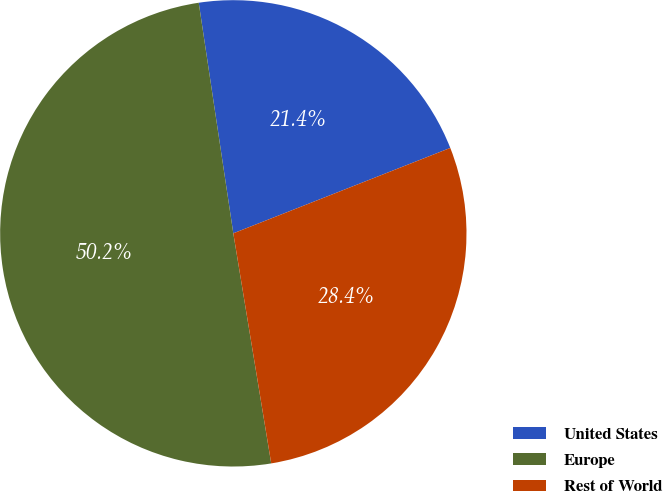<chart> <loc_0><loc_0><loc_500><loc_500><pie_chart><fcel>United States<fcel>Europe<fcel>Rest of World<nl><fcel>21.4%<fcel>50.23%<fcel>28.37%<nl></chart> 